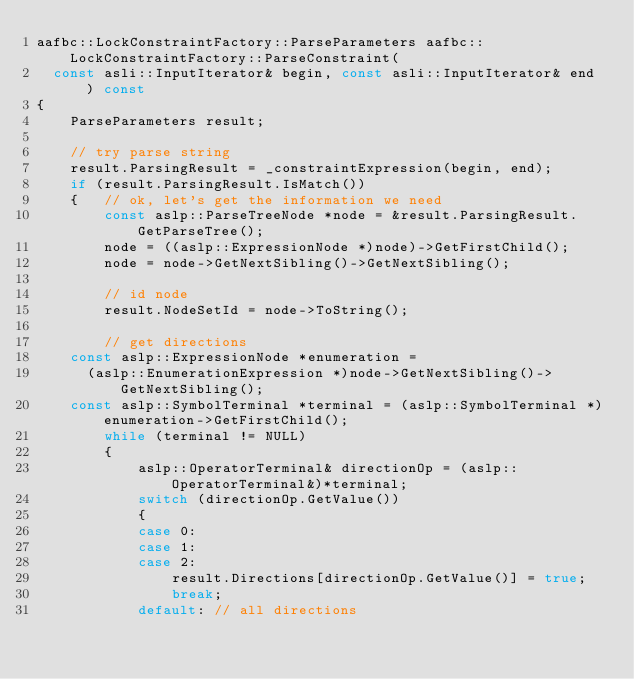Convert code to text. <code><loc_0><loc_0><loc_500><loc_500><_C++_>aafbc::LockConstraintFactory::ParseParameters aafbc::LockConstraintFactory::ParseConstraint(
  const asli::InputIterator& begin, const asli::InputIterator& end ) const
{
	ParseParameters result;

	// try parse string
	result.ParsingResult = _constraintExpression(begin, end);
	if (result.ParsingResult.IsMatch())
	{	// ok, let's get the information we need
		const aslp::ParseTreeNode *node = &result.ParsingResult.GetParseTree();
		node = ((aslp::ExpressionNode *)node)->GetFirstChild();
		node = node->GetNextSibling()->GetNextSibling();

		// id node
		result.NodeSetId = node->ToString();

		// get directions
    const aslp::ExpressionNode *enumeration = 
      (aslp::EnumerationExpression *)node->GetNextSibling()->GetNextSibling();
    const aslp::SymbolTerminal *terminal = (aslp::SymbolTerminal *)enumeration->GetFirstChild();
		while (terminal != NULL)
		{
			aslp::OperatorTerminal& directionOp = (aslp::OperatorTerminal&)*terminal;
			switch (directionOp.GetValue())
			{
			case 0:
			case 1:
			case 2:
				result.Directions[directionOp.GetValue()] = true;
				break;
			default: // all directions</code> 